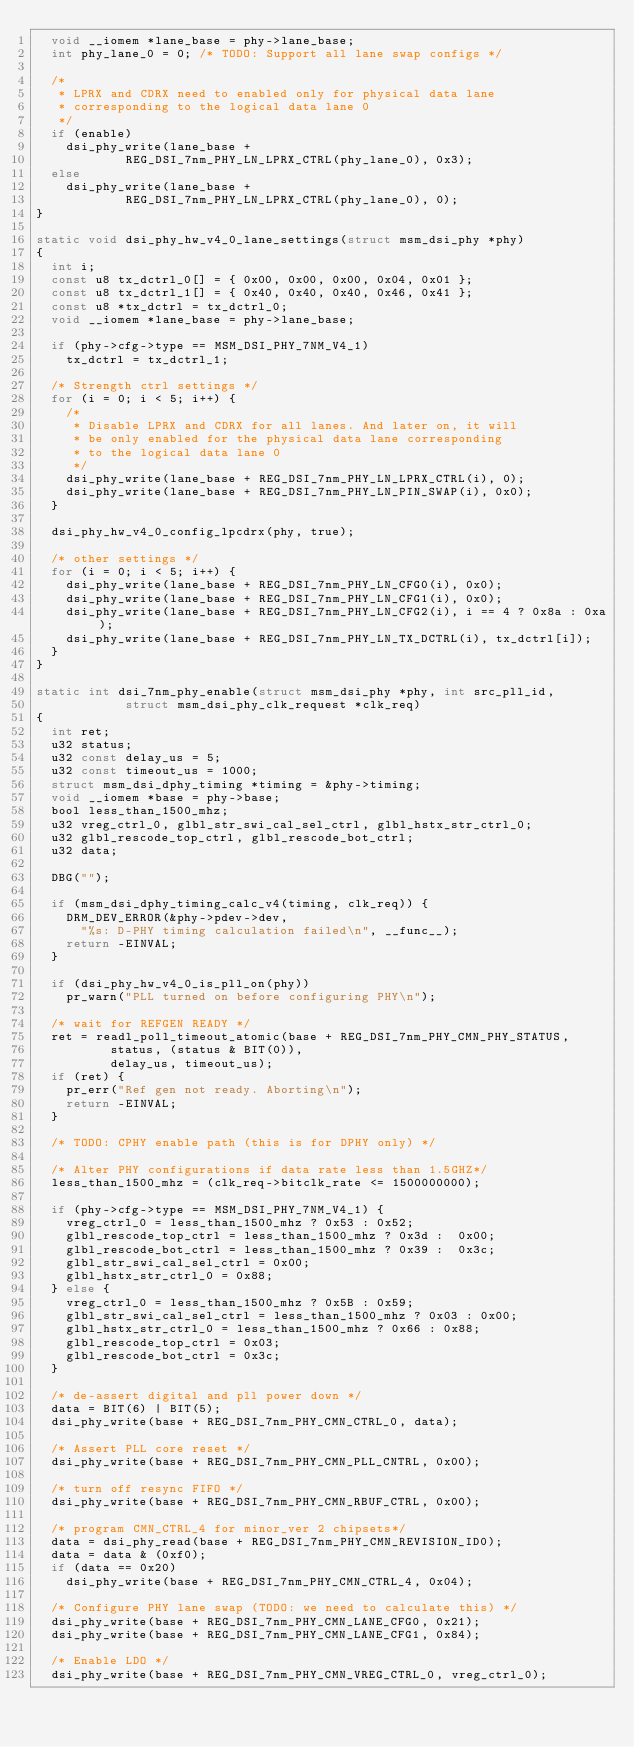<code> <loc_0><loc_0><loc_500><loc_500><_C_>	void __iomem *lane_base = phy->lane_base;
	int phy_lane_0 = 0;	/* TODO: Support all lane swap configs */

	/*
	 * LPRX and CDRX need to enabled only for physical data lane
	 * corresponding to the logical data lane 0
	 */
	if (enable)
		dsi_phy_write(lane_base +
			      REG_DSI_7nm_PHY_LN_LPRX_CTRL(phy_lane_0), 0x3);
	else
		dsi_phy_write(lane_base +
			      REG_DSI_7nm_PHY_LN_LPRX_CTRL(phy_lane_0), 0);
}

static void dsi_phy_hw_v4_0_lane_settings(struct msm_dsi_phy *phy)
{
	int i;
	const u8 tx_dctrl_0[] = { 0x00, 0x00, 0x00, 0x04, 0x01 };
	const u8 tx_dctrl_1[] = { 0x40, 0x40, 0x40, 0x46, 0x41 };
	const u8 *tx_dctrl = tx_dctrl_0;
	void __iomem *lane_base = phy->lane_base;

	if (phy->cfg->type == MSM_DSI_PHY_7NM_V4_1)
		tx_dctrl = tx_dctrl_1;

	/* Strength ctrl settings */
	for (i = 0; i < 5; i++) {
		/*
		 * Disable LPRX and CDRX for all lanes. And later on, it will
		 * be only enabled for the physical data lane corresponding
		 * to the logical data lane 0
		 */
		dsi_phy_write(lane_base + REG_DSI_7nm_PHY_LN_LPRX_CTRL(i), 0);
		dsi_phy_write(lane_base + REG_DSI_7nm_PHY_LN_PIN_SWAP(i), 0x0);
	}

	dsi_phy_hw_v4_0_config_lpcdrx(phy, true);

	/* other settings */
	for (i = 0; i < 5; i++) {
		dsi_phy_write(lane_base + REG_DSI_7nm_PHY_LN_CFG0(i), 0x0);
		dsi_phy_write(lane_base + REG_DSI_7nm_PHY_LN_CFG1(i), 0x0);
		dsi_phy_write(lane_base + REG_DSI_7nm_PHY_LN_CFG2(i), i == 4 ? 0x8a : 0xa);
		dsi_phy_write(lane_base + REG_DSI_7nm_PHY_LN_TX_DCTRL(i), tx_dctrl[i]);
	}
}

static int dsi_7nm_phy_enable(struct msm_dsi_phy *phy, int src_pll_id,
			      struct msm_dsi_phy_clk_request *clk_req)
{
	int ret;
	u32 status;
	u32 const delay_us = 5;
	u32 const timeout_us = 1000;
	struct msm_dsi_dphy_timing *timing = &phy->timing;
	void __iomem *base = phy->base;
	bool less_than_1500_mhz;
	u32 vreg_ctrl_0, glbl_str_swi_cal_sel_ctrl, glbl_hstx_str_ctrl_0;
	u32 glbl_rescode_top_ctrl, glbl_rescode_bot_ctrl;
	u32 data;

	DBG("");

	if (msm_dsi_dphy_timing_calc_v4(timing, clk_req)) {
		DRM_DEV_ERROR(&phy->pdev->dev,
			"%s: D-PHY timing calculation failed\n", __func__);
		return -EINVAL;
	}

	if (dsi_phy_hw_v4_0_is_pll_on(phy))
		pr_warn("PLL turned on before configuring PHY\n");

	/* wait for REFGEN READY */
	ret = readl_poll_timeout_atomic(base + REG_DSI_7nm_PHY_CMN_PHY_STATUS,
					status, (status & BIT(0)),
					delay_us, timeout_us);
	if (ret) {
		pr_err("Ref gen not ready. Aborting\n");
		return -EINVAL;
	}

	/* TODO: CPHY enable path (this is for DPHY only) */

	/* Alter PHY configurations if data rate less than 1.5GHZ*/
	less_than_1500_mhz = (clk_req->bitclk_rate <= 1500000000);

	if (phy->cfg->type == MSM_DSI_PHY_7NM_V4_1) {
		vreg_ctrl_0 = less_than_1500_mhz ? 0x53 : 0x52;
		glbl_rescode_top_ctrl = less_than_1500_mhz ? 0x3d :  0x00;
		glbl_rescode_bot_ctrl = less_than_1500_mhz ? 0x39 :  0x3c;
		glbl_str_swi_cal_sel_ctrl = 0x00;
		glbl_hstx_str_ctrl_0 = 0x88;
	} else {
		vreg_ctrl_0 = less_than_1500_mhz ? 0x5B : 0x59;
		glbl_str_swi_cal_sel_ctrl = less_than_1500_mhz ? 0x03 : 0x00;
		glbl_hstx_str_ctrl_0 = less_than_1500_mhz ? 0x66 : 0x88;
		glbl_rescode_top_ctrl = 0x03;
		glbl_rescode_bot_ctrl = 0x3c;
	}

	/* de-assert digital and pll power down */
	data = BIT(6) | BIT(5);
	dsi_phy_write(base + REG_DSI_7nm_PHY_CMN_CTRL_0, data);

	/* Assert PLL core reset */
	dsi_phy_write(base + REG_DSI_7nm_PHY_CMN_PLL_CNTRL, 0x00);

	/* turn off resync FIFO */
	dsi_phy_write(base + REG_DSI_7nm_PHY_CMN_RBUF_CTRL, 0x00);

	/* program CMN_CTRL_4 for minor_ver 2 chipsets*/
	data = dsi_phy_read(base + REG_DSI_7nm_PHY_CMN_REVISION_ID0);
	data = data & (0xf0);
	if (data == 0x20)
		dsi_phy_write(base + REG_DSI_7nm_PHY_CMN_CTRL_4, 0x04);

	/* Configure PHY lane swap (TODO: we need to calculate this) */
	dsi_phy_write(base + REG_DSI_7nm_PHY_CMN_LANE_CFG0, 0x21);
	dsi_phy_write(base + REG_DSI_7nm_PHY_CMN_LANE_CFG1, 0x84);

	/* Enable LDO */
	dsi_phy_write(base + REG_DSI_7nm_PHY_CMN_VREG_CTRL_0, vreg_ctrl_0);</code> 